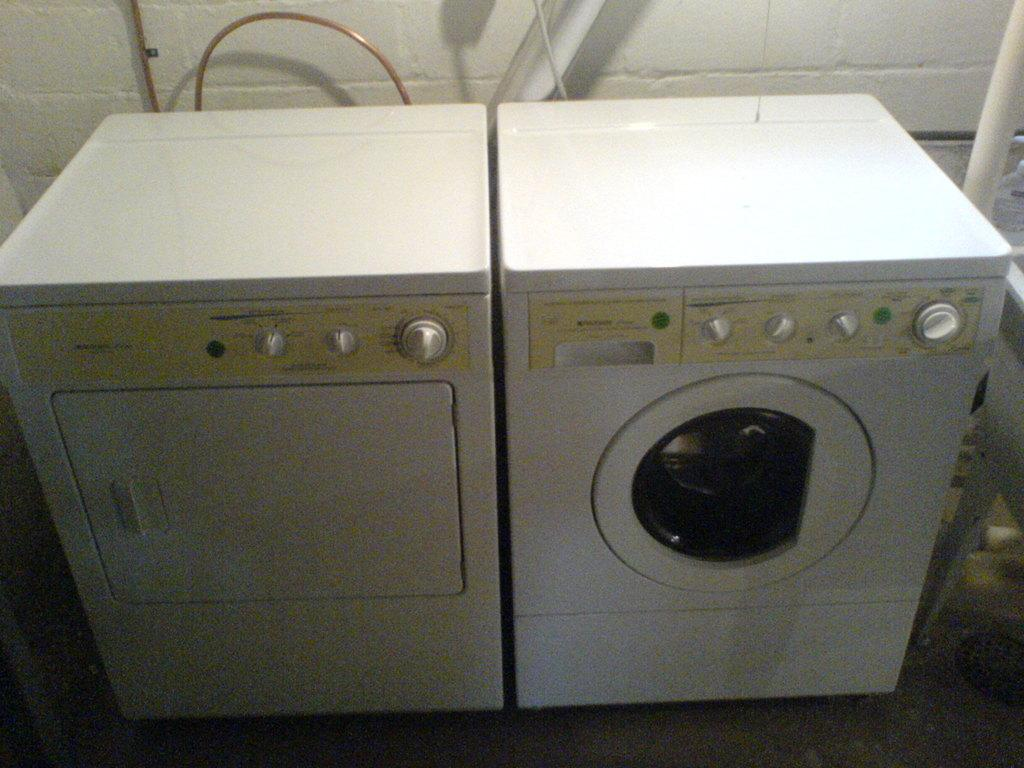What type of appliances can be seen in the image? There are washing machines in the image. Where are the washing machines located in relation to other objects? The washing machines are placed near a wall. What additional feature can be seen in the image? There are copper pipes visible at the top left of the image. Can you see any goldfish swimming near the washing machines in the image? No, there are no goldfish present in the image. 